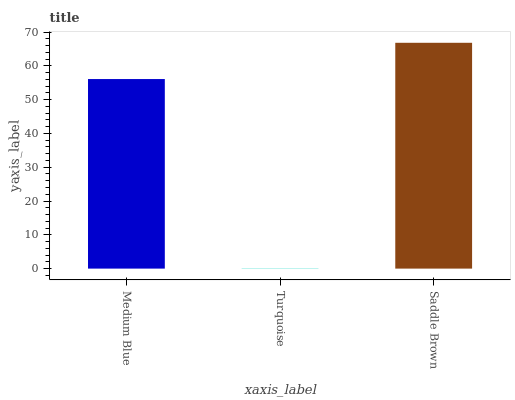Is Turquoise the minimum?
Answer yes or no. Yes. Is Saddle Brown the maximum?
Answer yes or no. Yes. Is Saddle Brown the minimum?
Answer yes or no. No. Is Turquoise the maximum?
Answer yes or no. No. Is Saddle Brown greater than Turquoise?
Answer yes or no. Yes. Is Turquoise less than Saddle Brown?
Answer yes or no. Yes. Is Turquoise greater than Saddle Brown?
Answer yes or no. No. Is Saddle Brown less than Turquoise?
Answer yes or no. No. Is Medium Blue the high median?
Answer yes or no. Yes. Is Medium Blue the low median?
Answer yes or no. Yes. Is Saddle Brown the high median?
Answer yes or no. No. Is Saddle Brown the low median?
Answer yes or no. No. 